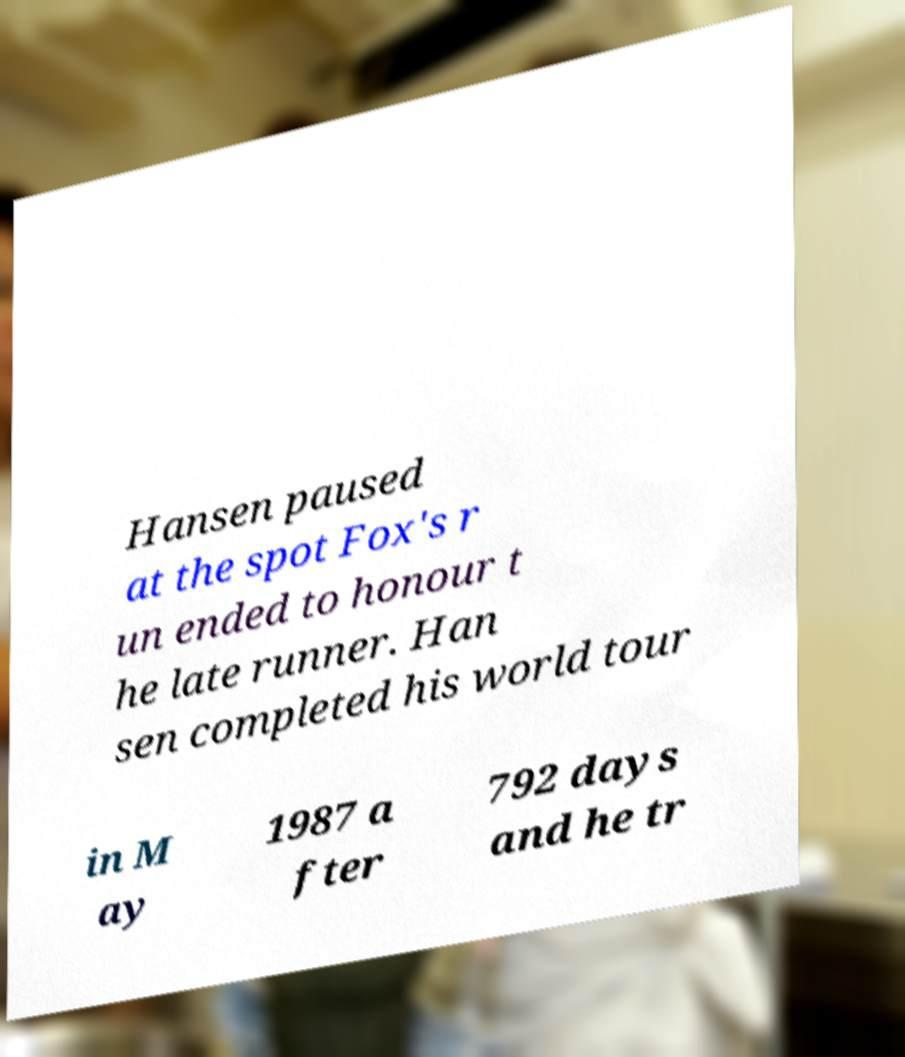I need the written content from this picture converted into text. Can you do that? Hansen paused at the spot Fox's r un ended to honour t he late runner. Han sen completed his world tour in M ay 1987 a fter 792 days and he tr 